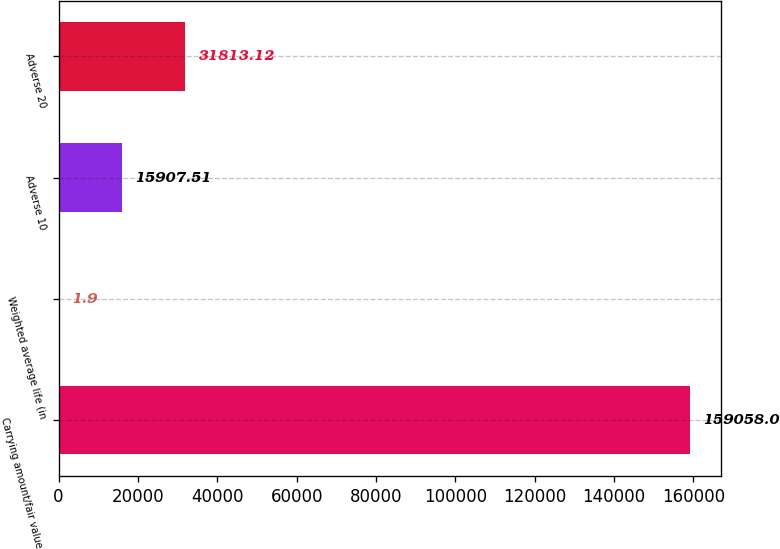Convert chart. <chart><loc_0><loc_0><loc_500><loc_500><bar_chart><fcel>Carrying amount/fair value of<fcel>Weighted average life (in<fcel>Adverse 10<fcel>Adverse 20<nl><fcel>159058<fcel>1.9<fcel>15907.5<fcel>31813.1<nl></chart> 